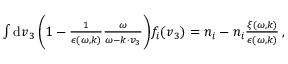Convert formula to latex. <formula><loc_0><loc_0><loc_500><loc_500>\begin{array} { r } { \int d v _ { 3 } \, \left ( 1 - \frac { 1 } { \epsilon ( \omega , k ) } \frac { \omega } { \omega - k \cdot v _ { 3 } } \right ) f _ { i } ( v _ { 3 } ) = n _ { i } - n _ { i } \frac { \xi ( \omega , k ) } { \epsilon ( \omega , k ) } \, , } \end{array}</formula> 